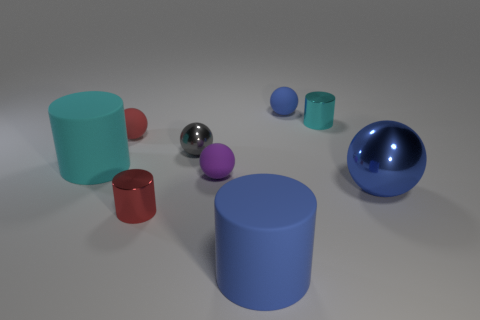Subtract all purple spheres. How many spheres are left? 4 Subtract all small shiny spheres. How many spheres are left? 4 Subtract all brown balls. Subtract all red blocks. How many balls are left? 5 Subtract all cylinders. How many objects are left? 5 Add 5 small red shiny cylinders. How many small red shiny cylinders are left? 6 Add 2 blue cylinders. How many blue cylinders exist? 3 Subtract 0 green cubes. How many objects are left? 9 Subtract all green objects. Subtract all big blue matte things. How many objects are left? 8 